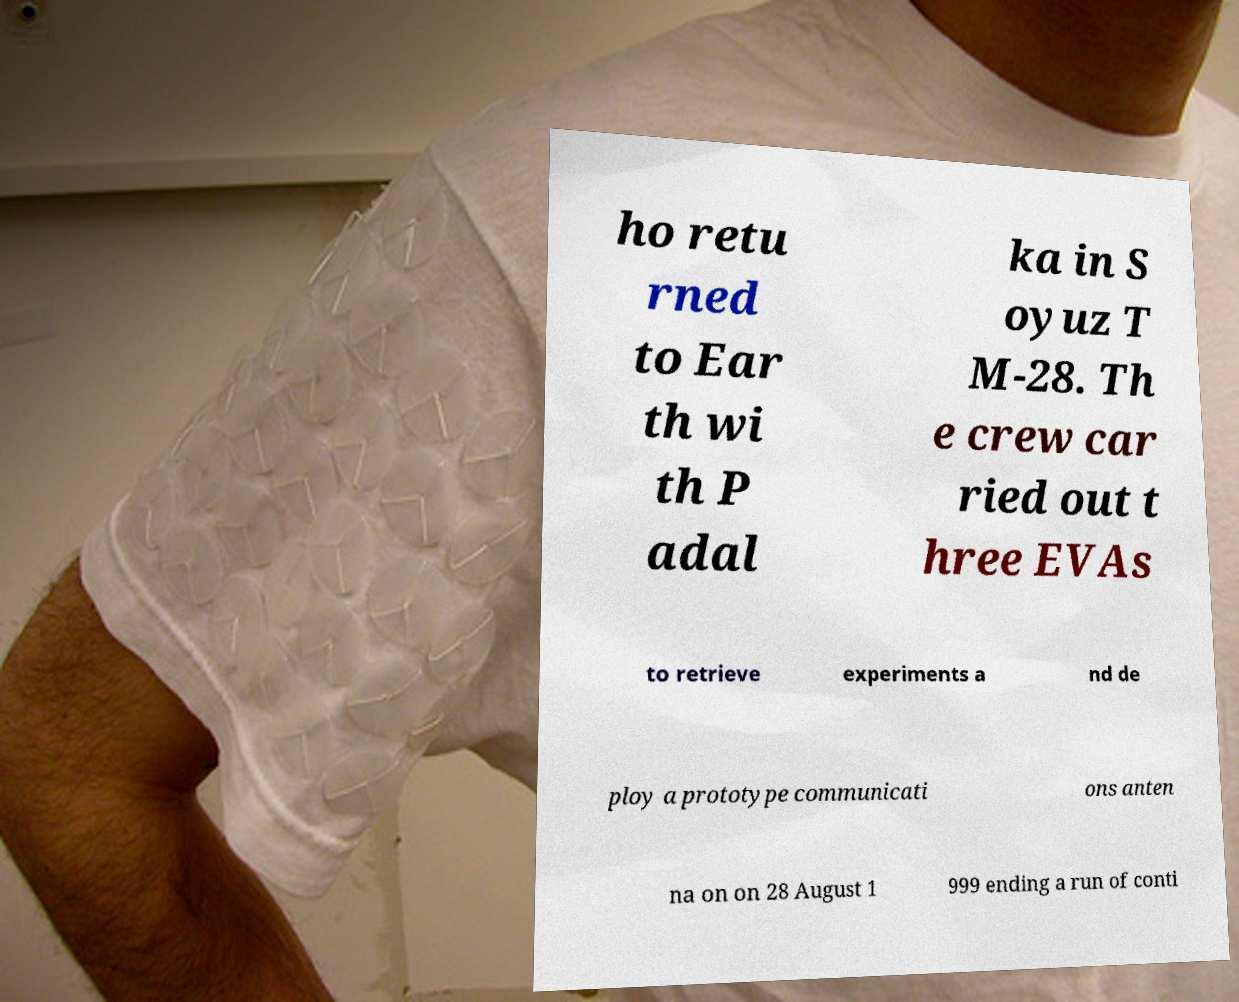Please read and relay the text visible in this image. What does it say? ho retu rned to Ear th wi th P adal ka in S oyuz T M-28. Th e crew car ried out t hree EVAs to retrieve experiments a nd de ploy a prototype communicati ons anten na on on 28 August 1 999 ending a run of conti 